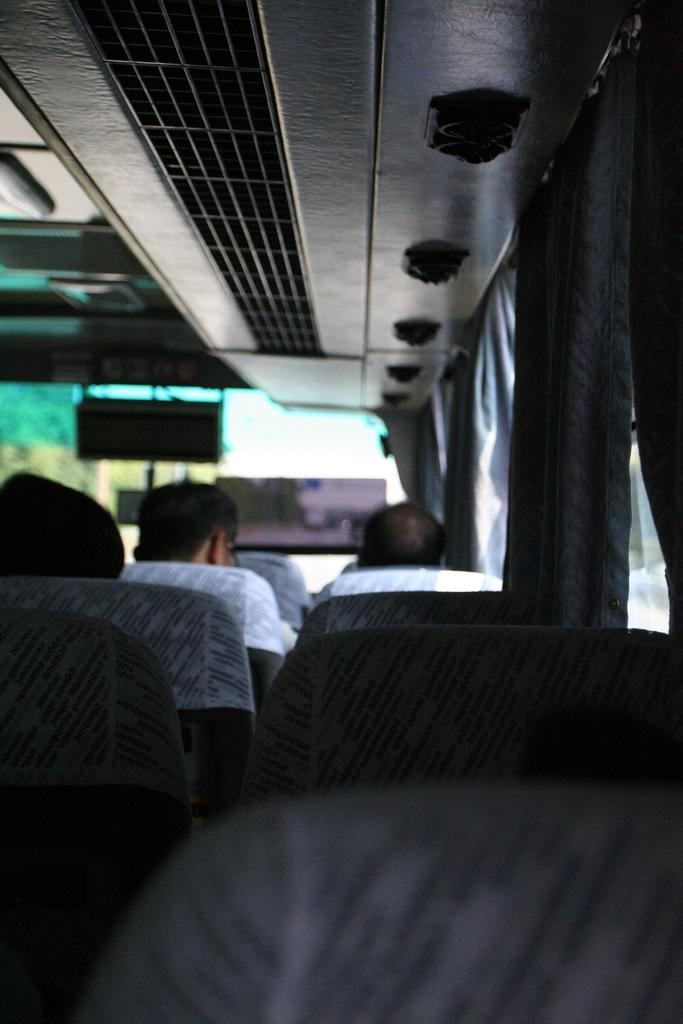What are the people in the image doing? The people in the image are sitting on the bus seats. What feature is present at the top of the image? AC ducts are present at the top of the image. What type of covering is visible on the windows in the image? Window curtains are visible in the image. How many apples are hanging from the leaf in the image? There is no leaf or apples present in the image. 